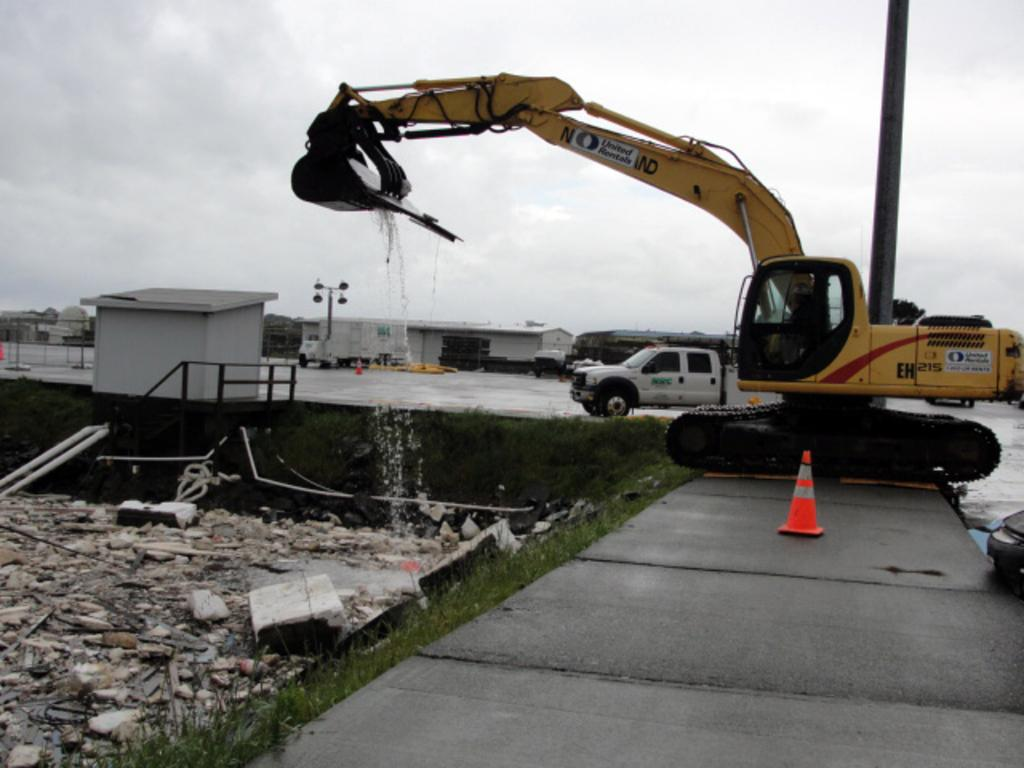What type of structures can be seen in the image? There are houses in the image. What construction equipment is present in the image? There is a crane in the image. What type of vehicle is visible in the image? There is a mini truck in the image. What type of lighting is present in the image? There are pole lights in the image. How would you describe the weather based on the image? The sky is cloudy in the image. What object can be seen on the sidewalk in the image? There is a cone on the sidewalk in the image. What type of quartz can be seen in the image? There is no quartz present in the image. Can you tell me how many rabbits are visible in the image? There are no rabbits present in the image. 